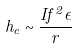<formula> <loc_0><loc_0><loc_500><loc_500>h _ { c } \sim \frac { I f ^ { 2 } \epsilon } { r }</formula> 